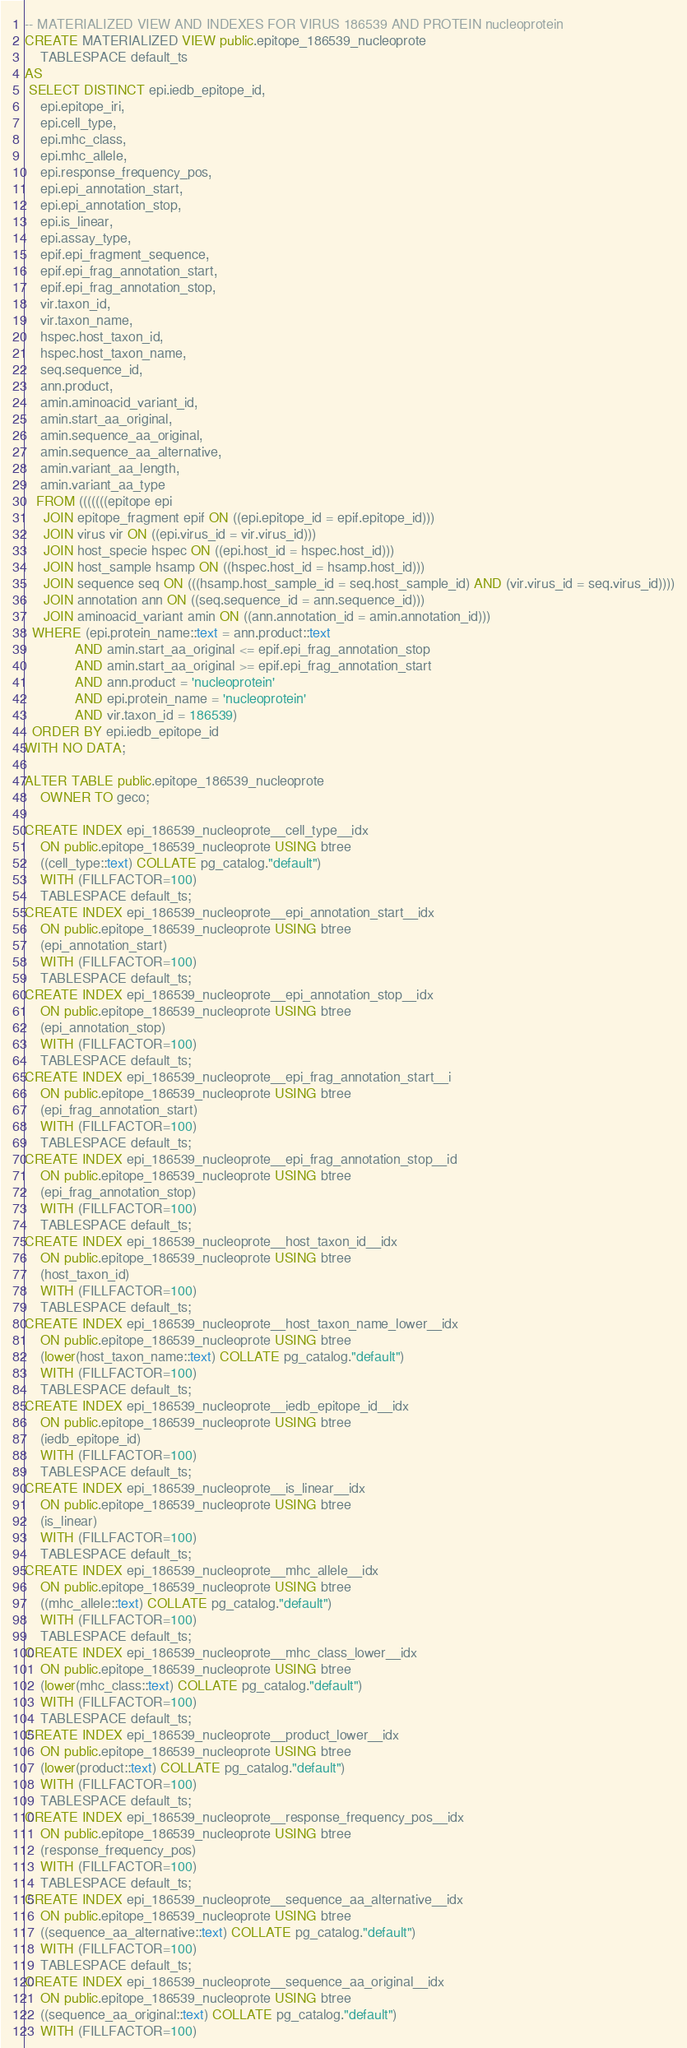Convert code to text. <code><loc_0><loc_0><loc_500><loc_500><_SQL_>-- MATERIALIZED VIEW AND INDEXES FOR VIRUS 186539 AND PROTEIN nucleoprotein
CREATE MATERIALIZED VIEW public.epitope_186539_nucleoprote
    TABLESPACE default_ts
AS
 SELECT DISTINCT epi.iedb_epitope_id,
    epi.epitope_iri,
    epi.cell_type,
    epi.mhc_class,
    epi.mhc_allele,
    epi.response_frequency_pos,
    epi.epi_annotation_start,
    epi.epi_annotation_stop,
    epi.is_linear,
    epi.assay_type,
    epif.epi_fragment_sequence,
    epif.epi_frag_annotation_start,
    epif.epi_frag_annotation_stop,
    vir.taxon_id,
    vir.taxon_name,
    hspec.host_taxon_id,
    hspec.host_taxon_name,
    seq.sequence_id,
    ann.product,
    amin.aminoacid_variant_id,
    amin.start_aa_original,
    amin.sequence_aa_original,
    amin.sequence_aa_alternative,
    amin.variant_aa_length,
    amin.variant_aa_type
   FROM (((((((epitope epi
     JOIN epitope_fragment epif ON ((epi.epitope_id = epif.epitope_id)))
     JOIN virus vir ON ((epi.virus_id = vir.virus_id)))
     JOIN host_specie hspec ON ((epi.host_id = hspec.host_id)))
     JOIN host_sample hsamp ON ((hspec.host_id = hsamp.host_id)))
     JOIN sequence seq ON (((hsamp.host_sample_id = seq.host_sample_id) AND (vir.virus_id = seq.virus_id))))
     JOIN annotation ann ON ((seq.sequence_id = ann.sequence_id)))
     JOIN aminoacid_variant amin ON ((ann.annotation_id = amin.annotation_id)))
  WHERE (epi.protein_name::text = ann.product::text
             AND amin.start_aa_original <= epif.epi_frag_annotation_stop
             AND amin.start_aa_original >= epif.epi_frag_annotation_start
             AND ann.product = 'nucleoprotein'
             AND epi.protein_name = 'nucleoprotein'
             AND vir.taxon_id = 186539)
  ORDER BY epi.iedb_epitope_id
WITH NO DATA;

ALTER TABLE public.epitope_186539_nucleoprote
    OWNER TO geco;

CREATE INDEX epi_186539_nucleoprote__cell_type__idx
    ON public.epitope_186539_nucleoprote USING btree
    ((cell_type::text) COLLATE pg_catalog."default")
    WITH (FILLFACTOR=100)
    TABLESPACE default_ts;
CREATE INDEX epi_186539_nucleoprote__epi_annotation_start__idx
    ON public.epitope_186539_nucleoprote USING btree
    (epi_annotation_start)
    WITH (FILLFACTOR=100)
    TABLESPACE default_ts;
CREATE INDEX epi_186539_nucleoprote__epi_annotation_stop__idx
    ON public.epitope_186539_nucleoprote USING btree
    (epi_annotation_stop)
    WITH (FILLFACTOR=100)
    TABLESPACE default_ts;
CREATE INDEX epi_186539_nucleoprote__epi_frag_annotation_start__i
    ON public.epitope_186539_nucleoprote USING btree
    (epi_frag_annotation_start)
    WITH (FILLFACTOR=100)
    TABLESPACE default_ts;
CREATE INDEX epi_186539_nucleoprote__epi_frag_annotation_stop__id
    ON public.epitope_186539_nucleoprote USING btree
    (epi_frag_annotation_stop)
    WITH (FILLFACTOR=100)
    TABLESPACE default_ts;
CREATE INDEX epi_186539_nucleoprote__host_taxon_id__idx
    ON public.epitope_186539_nucleoprote USING btree
    (host_taxon_id)
    WITH (FILLFACTOR=100)
    TABLESPACE default_ts;
CREATE INDEX epi_186539_nucleoprote__host_taxon_name_lower__idx
    ON public.epitope_186539_nucleoprote USING btree
    (lower(host_taxon_name::text) COLLATE pg_catalog."default")
    WITH (FILLFACTOR=100)
    TABLESPACE default_ts;
CREATE INDEX epi_186539_nucleoprote__iedb_epitope_id__idx
    ON public.epitope_186539_nucleoprote USING btree
    (iedb_epitope_id)
    WITH (FILLFACTOR=100)
    TABLESPACE default_ts;
CREATE INDEX epi_186539_nucleoprote__is_linear__idx
    ON public.epitope_186539_nucleoprote USING btree
    (is_linear)
    WITH (FILLFACTOR=100)
    TABLESPACE default_ts;
CREATE INDEX epi_186539_nucleoprote__mhc_allele__idx
    ON public.epitope_186539_nucleoprote USING btree
    ((mhc_allele::text) COLLATE pg_catalog."default")
    WITH (FILLFACTOR=100)
    TABLESPACE default_ts;
CREATE INDEX epi_186539_nucleoprote__mhc_class_lower__idx
    ON public.epitope_186539_nucleoprote USING btree
    (lower(mhc_class::text) COLLATE pg_catalog."default")
    WITH (FILLFACTOR=100)
    TABLESPACE default_ts;
CREATE INDEX epi_186539_nucleoprote__product_lower__idx
    ON public.epitope_186539_nucleoprote USING btree
    (lower(product::text) COLLATE pg_catalog."default")
    WITH (FILLFACTOR=100)
    TABLESPACE default_ts;
CREATE INDEX epi_186539_nucleoprote__response_frequency_pos__idx
    ON public.epitope_186539_nucleoprote USING btree
    (response_frequency_pos)
    WITH (FILLFACTOR=100)
    TABLESPACE default_ts;
CREATE INDEX epi_186539_nucleoprote__sequence_aa_alternative__idx
    ON public.epitope_186539_nucleoprote USING btree
    ((sequence_aa_alternative::text) COLLATE pg_catalog."default")
    WITH (FILLFACTOR=100)
    TABLESPACE default_ts;
CREATE INDEX epi_186539_nucleoprote__sequence_aa_original__idx
    ON public.epitope_186539_nucleoprote USING btree
    ((sequence_aa_original::text) COLLATE pg_catalog."default")
    WITH (FILLFACTOR=100)</code> 